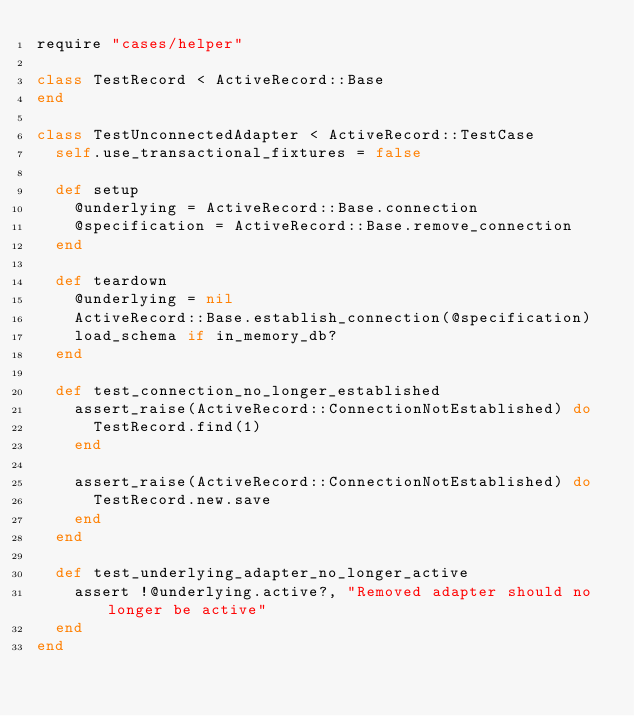<code> <loc_0><loc_0><loc_500><loc_500><_Ruby_>require "cases/helper"

class TestRecord < ActiveRecord::Base
end

class TestUnconnectedAdapter < ActiveRecord::TestCase
  self.use_transactional_fixtures = false

  def setup
    @underlying = ActiveRecord::Base.connection
    @specification = ActiveRecord::Base.remove_connection
  end

  def teardown
    @underlying = nil
    ActiveRecord::Base.establish_connection(@specification)
    load_schema if in_memory_db?
  end

  def test_connection_no_longer_established
    assert_raise(ActiveRecord::ConnectionNotEstablished) do
      TestRecord.find(1)
    end

    assert_raise(ActiveRecord::ConnectionNotEstablished) do
      TestRecord.new.save
    end
  end

  def test_underlying_adapter_no_longer_active
    assert !@underlying.active?, "Removed adapter should no longer be active"
  end
end
</code> 